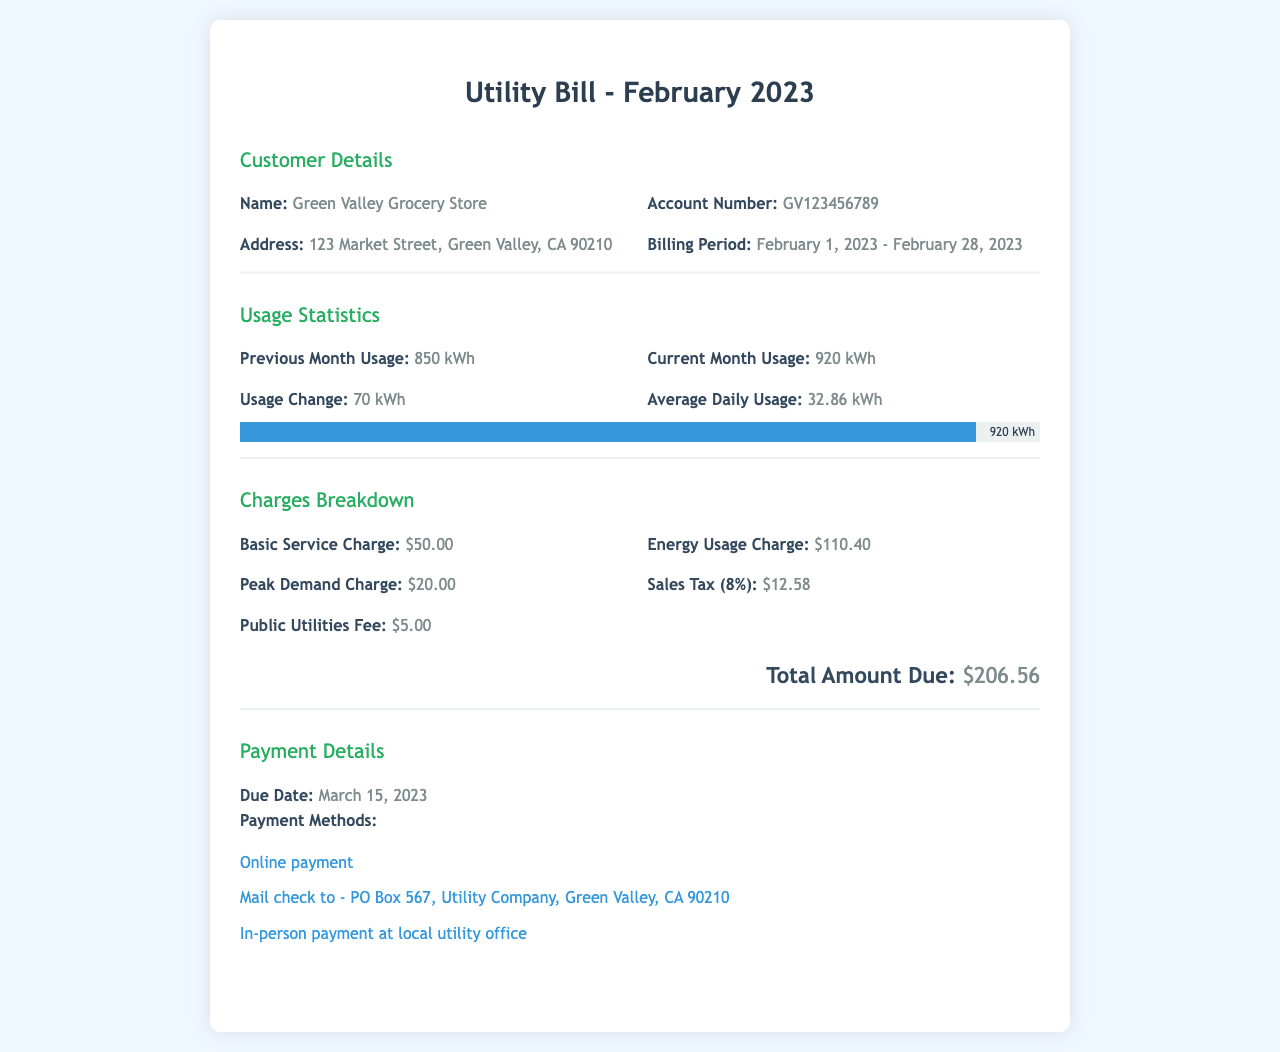What is the account number? The account number is listed in the customer details section of the document as GV123456789.
Answer: GV123456789 What is the billing period? The billing period is detailed in the customer details section as February 1, 2023 - February 28, 2023.
Answer: February 1, 2023 - February 28, 2023 How much was the current month usage? The current month usage is found in the usage statistics section, which states it was 920 kWh.
Answer: 920 kWh What is the sales tax amount? The sales tax amount is part of the charges breakdown and is indicated as $12.58.
Answer: $12.58 What is the total amount due? The total amount due is given in the charges breakdown, clearly listed as $206.56.
Answer: $206.56 How much did energy usage charge increase? The reasoning involves comparing the current month's and previous month's usage; the increase was 70 kWh.
Answer: 70 kWh What are the payment methods? The payment details section lists various options for payment including online payment and mail check.
Answer: Online payment, Mail check to - PO Box 567, Utility Company, Green Valley, CA 90210, In-person payment at local utility office When is the due date for payment? The due date is specified in the payment details section as March 15, 2023.
Answer: March 15, 2023 What was the basic service charge? The basic service charge is mentioned in the charges breakdown, and it is $50.00.
Answer: $50.00 